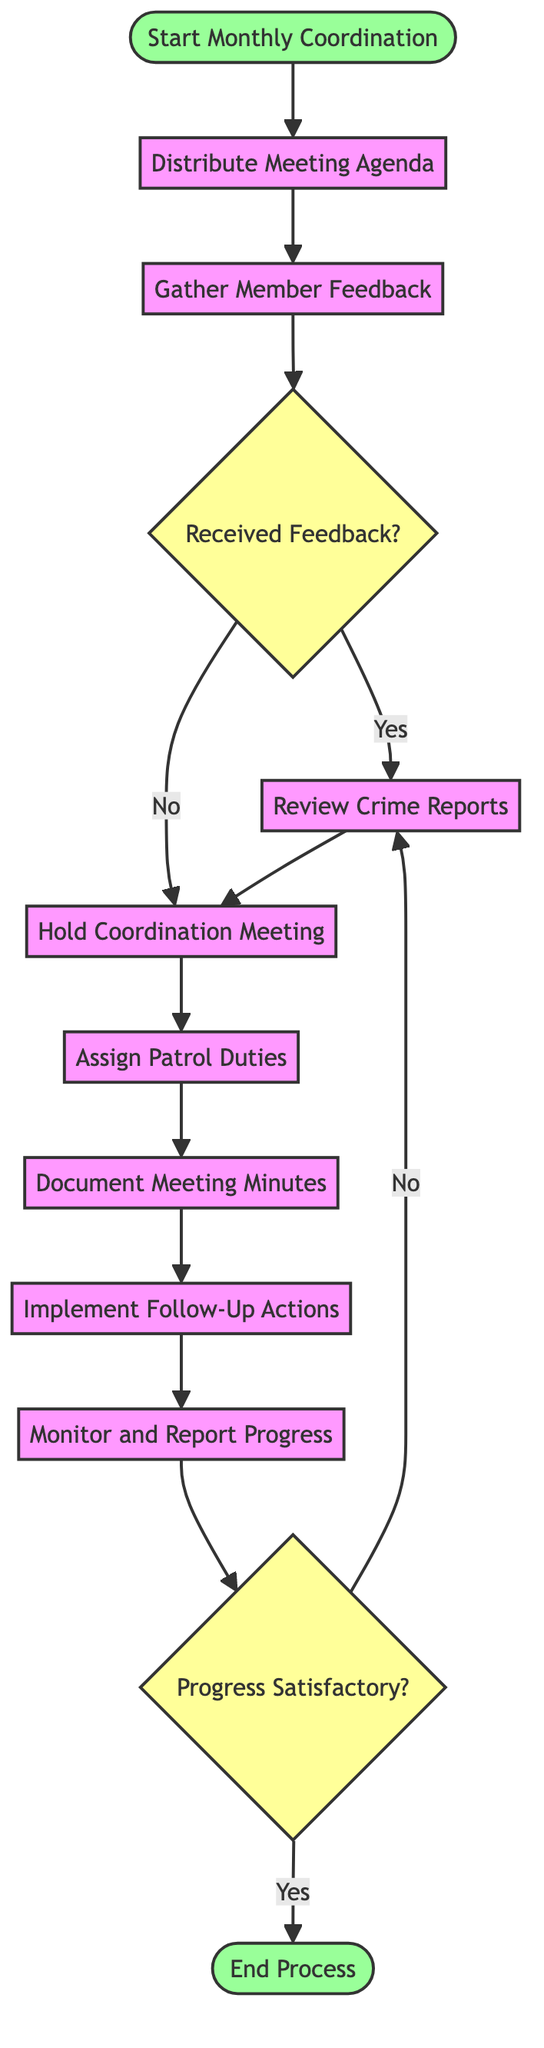What is the starting point of the activity diagram? The diagram begins at the node labeled "Start Monthly Coordination." This node signifies the initiation of the entire process outlined in the activity diagram.
Answer: Start Monthly Coordination How many activities are listed in the diagram? By counting the activities represented in the diagram, we see there are eight distinct activities including distributing the agenda and monitoring progress.
Answer: 8 What is the decision point after gathering member feedback? After gathering feedback, the decision point is labeled "Received Feedback?" and leads to two possible actions based on whether feedback was received or not.
Answer: Received Feedback? What activity follows the "Hold Coordination Meeting"? Once the coordination meeting is held, the next step in the process is to "Assign Patrol Duties," continuing the flow of activities related to neighborhood watch coordination.
Answer: Assign Patrol Duties What happens if progress is satisfactory? If the progress is satisfactory, the flow transitions to the end point of the process, marking the conclusion of the activities described in the diagram.
Answer: End Process What follows if feedback is not received? If feedback is not received, the flow skips to "Hold Coordination Meeting," indicating that the meeting will proceed regardless of member feedback, ensuring continuity in coordination efforts.
Answer: Hold Coordination Meeting How many decision points are present in the diagram? There are two distinct decision points within the diagram, which guide the flow based on member feedback and the satisfaction of progress.
Answer: 2 What is the final step taken in the process? The final step in the diagram, as indicated by the end point, is labeled "End Process," signifying that all activities are concluded after monitoring progress.
Answer: End Process 